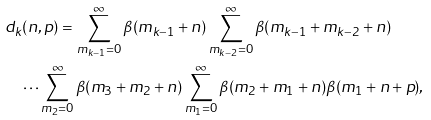Convert formula to latex. <formula><loc_0><loc_0><loc_500><loc_500>& d _ { k } ( n , p ) = \sum _ { m _ { k - 1 } = 0 } ^ { \infty } \beta ( m _ { k - 1 } + n ) \sum _ { m _ { k - 2 } = 0 } ^ { \infty } \beta ( m _ { k - 1 } + m _ { k - 2 } + n ) \\ & \quad \cdots \sum _ { m _ { 2 } = 0 } ^ { \infty } \beta ( m _ { 3 } + m _ { 2 } + n ) \sum _ { m _ { 1 } = 0 } ^ { \infty } \beta ( m _ { 2 } + m _ { 1 } + n ) \beta ( m _ { 1 } + n + p ) ,</formula> 